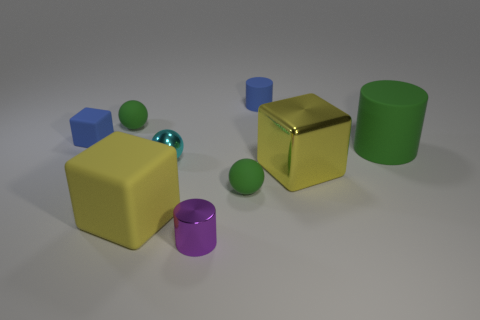There is a cylinder behind the big green thing; is it the same color as the tiny metallic sphere?
Give a very brief answer. No. What is the material of the cube on the right side of the tiny cyan shiny object?
Offer a terse response. Metal. How big is the cyan shiny ball?
Give a very brief answer. Small. Is the material of the yellow thing to the left of the cyan metal sphere the same as the purple thing?
Keep it short and to the point. No. What number of red matte spheres are there?
Keep it short and to the point. 0. How many objects are either yellow things or large yellow metallic objects?
Offer a very short reply. 2. What number of small things are in front of the matte cylinder right of the yellow cube on the right side of the yellow rubber cube?
Offer a terse response. 3. Are there any other things that are the same color as the tiny cube?
Provide a succinct answer. Yes. Does the tiny shiny thing behind the purple cylinder have the same color as the large rubber object that is on the left side of the tiny blue cylinder?
Make the answer very short. No. Is the number of purple metal things to the left of the cyan metallic object greater than the number of small blue rubber blocks that are in front of the green rubber cylinder?
Your answer should be very brief. No. 